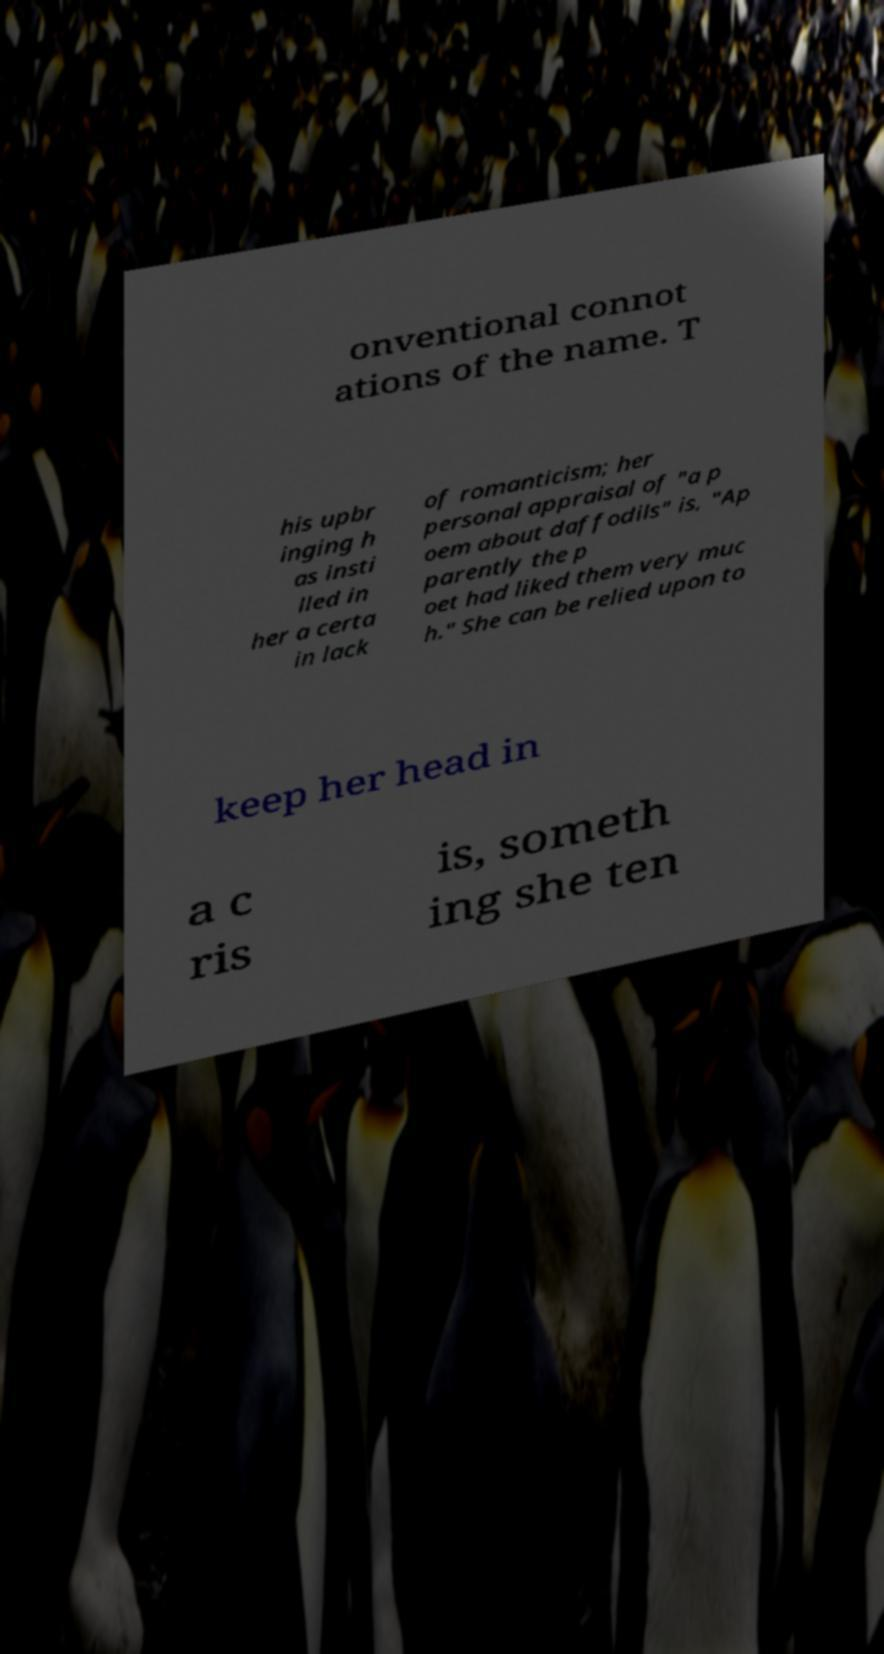What messages or text are displayed in this image? I need them in a readable, typed format. onventional connot ations of the name. T his upbr inging h as insti lled in her a certa in lack of romanticism; her personal appraisal of "a p oem about daffodils" is, "Ap parently the p oet had liked them very muc h." She can be relied upon to keep her head in a c ris is, someth ing she ten 